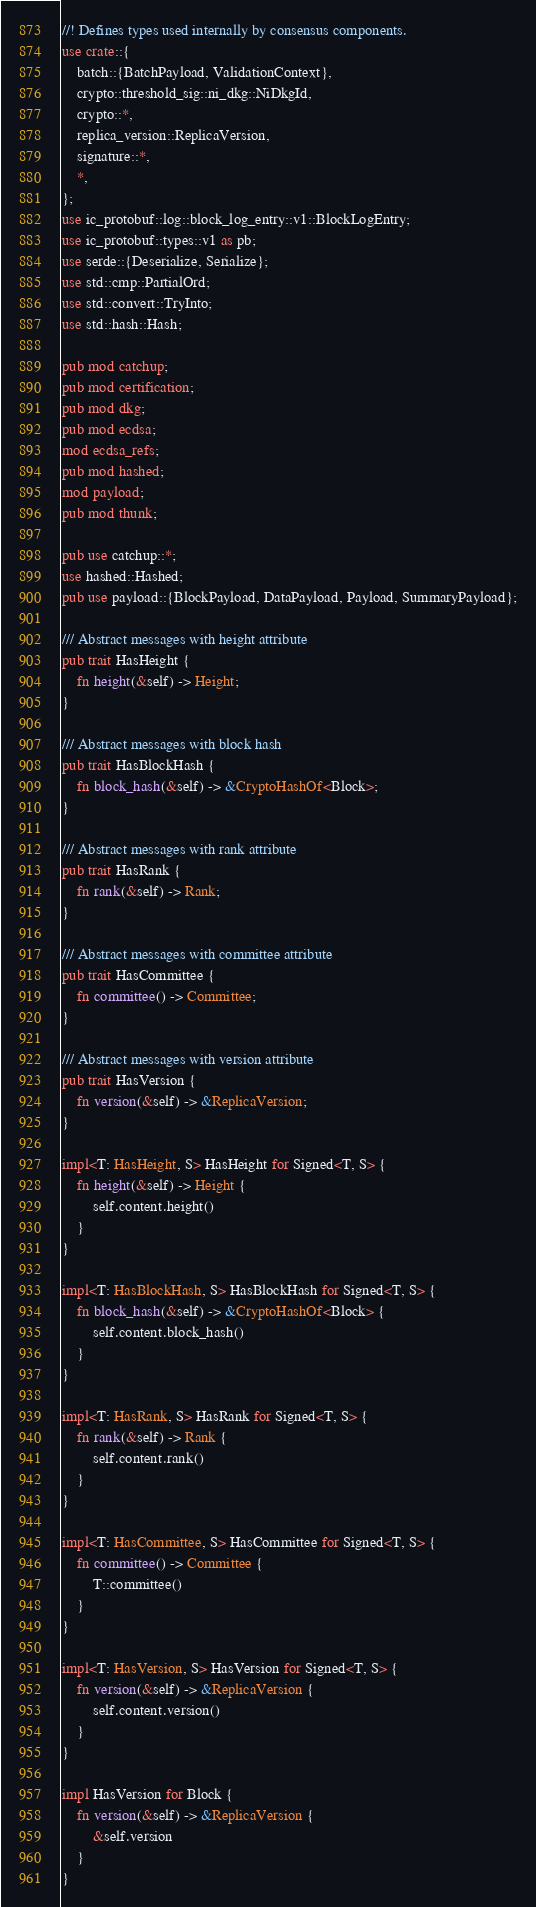Convert code to text. <code><loc_0><loc_0><loc_500><loc_500><_Rust_>//! Defines types used internally by consensus components.
use crate::{
    batch::{BatchPayload, ValidationContext},
    crypto::threshold_sig::ni_dkg::NiDkgId,
    crypto::*,
    replica_version::ReplicaVersion,
    signature::*,
    *,
};
use ic_protobuf::log::block_log_entry::v1::BlockLogEntry;
use ic_protobuf::types::v1 as pb;
use serde::{Deserialize, Serialize};
use std::cmp::PartialOrd;
use std::convert::TryInto;
use std::hash::Hash;

pub mod catchup;
pub mod certification;
pub mod dkg;
pub mod ecdsa;
mod ecdsa_refs;
pub mod hashed;
mod payload;
pub mod thunk;

pub use catchup::*;
use hashed::Hashed;
pub use payload::{BlockPayload, DataPayload, Payload, SummaryPayload};

/// Abstract messages with height attribute
pub trait HasHeight {
    fn height(&self) -> Height;
}

/// Abstract messages with block hash
pub trait HasBlockHash {
    fn block_hash(&self) -> &CryptoHashOf<Block>;
}

/// Abstract messages with rank attribute
pub trait HasRank {
    fn rank(&self) -> Rank;
}

/// Abstract messages with committee attribute
pub trait HasCommittee {
    fn committee() -> Committee;
}

/// Abstract messages with version attribute
pub trait HasVersion {
    fn version(&self) -> &ReplicaVersion;
}

impl<T: HasHeight, S> HasHeight for Signed<T, S> {
    fn height(&self) -> Height {
        self.content.height()
    }
}

impl<T: HasBlockHash, S> HasBlockHash for Signed<T, S> {
    fn block_hash(&self) -> &CryptoHashOf<Block> {
        self.content.block_hash()
    }
}

impl<T: HasRank, S> HasRank for Signed<T, S> {
    fn rank(&self) -> Rank {
        self.content.rank()
    }
}

impl<T: HasCommittee, S> HasCommittee for Signed<T, S> {
    fn committee() -> Committee {
        T::committee()
    }
}

impl<T: HasVersion, S> HasVersion for Signed<T, S> {
    fn version(&self) -> &ReplicaVersion {
        self.content.version()
    }
}

impl HasVersion for Block {
    fn version(&self) -> &ReplicaVersion {
        &self.version
    }
}
</code> 